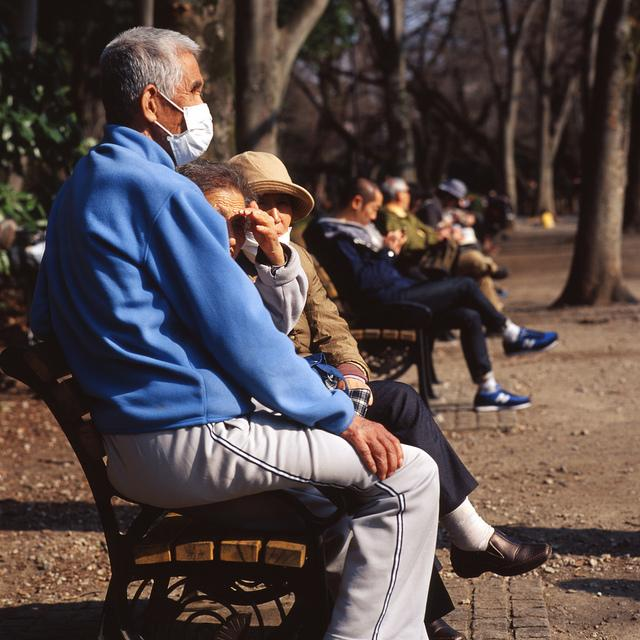What should the woman sitting in the middle wear for protection?

Choices:
A) scarf
B) hat
C) sunglasses
D) mittens sunglasses 